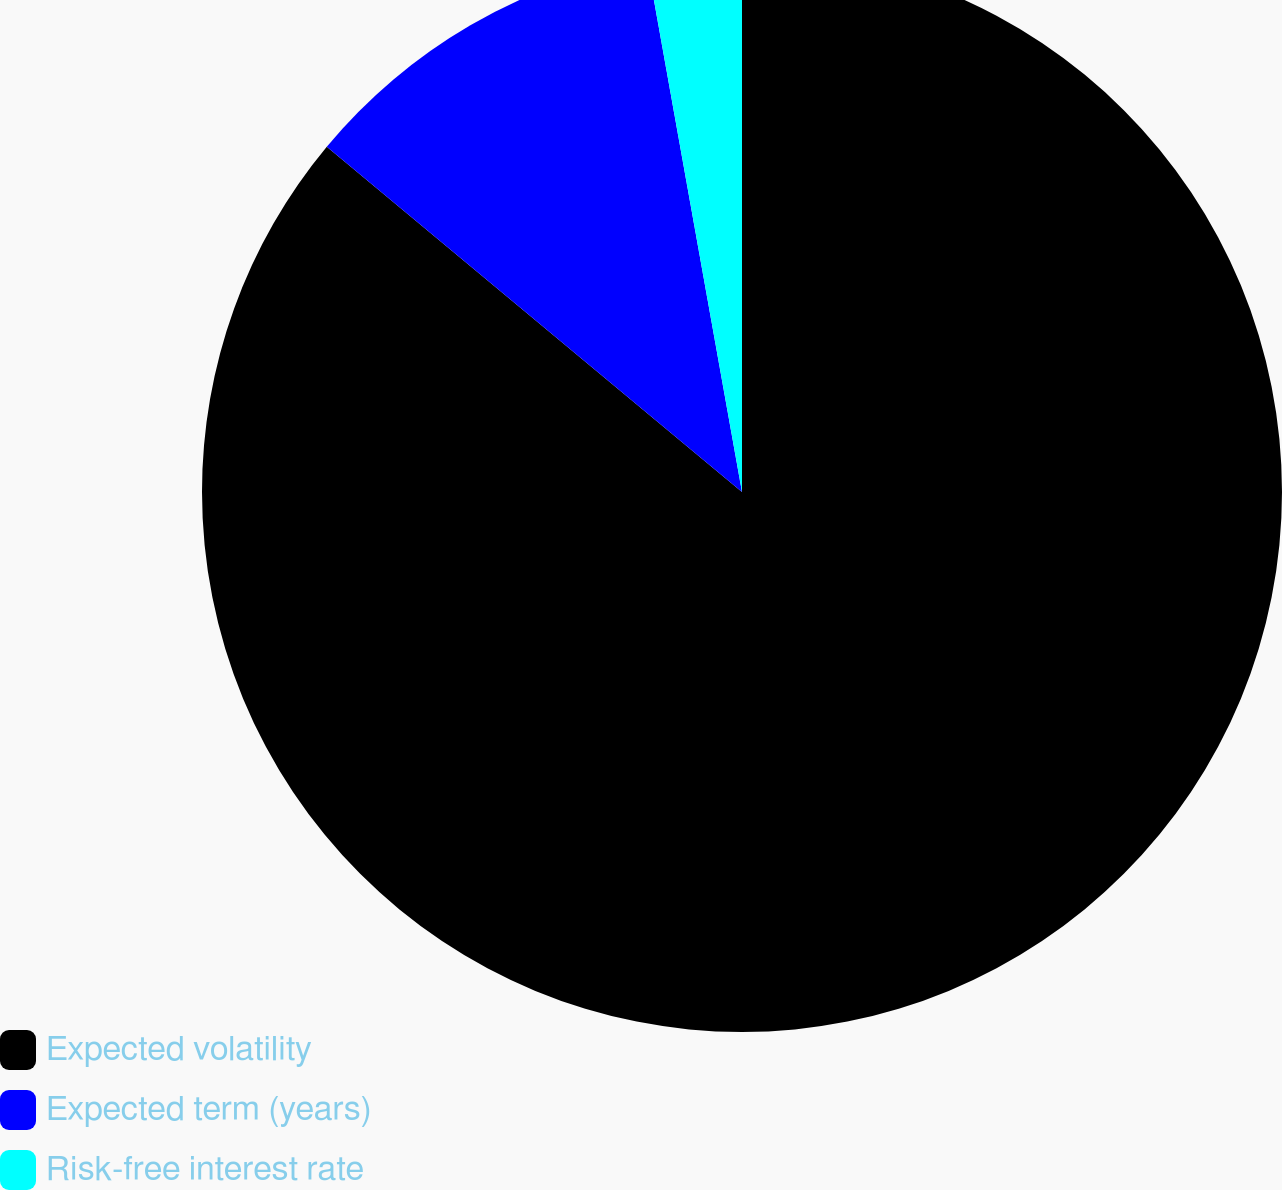<chart> <loc_0><loc_0><loc_500><loc_500><pie_chart><fcel>Expected volatility<fcel>Expected term (years)<fcel>Risk-free interest rate<nl><fcel>86.04%<fcel>11.14%<fcel>2.82%<nl></chart> 